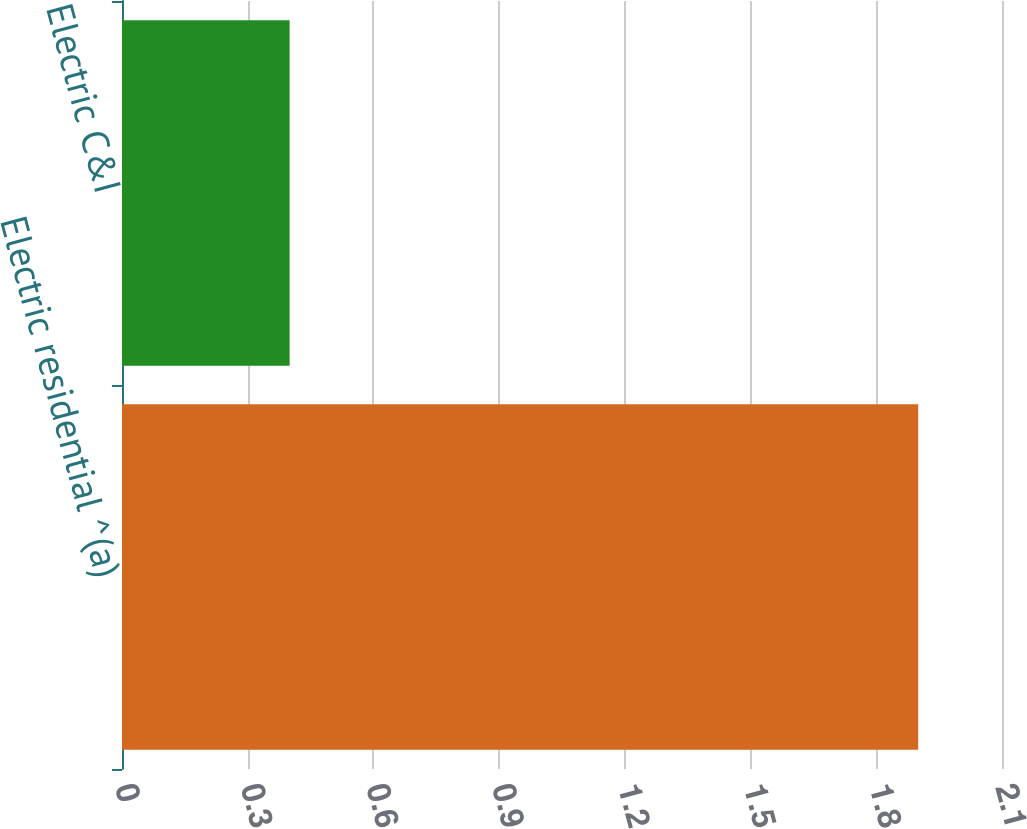Convert chart. <chart><loc_0><loc_0><loc_500><loc_500><bar_chart><fcel>Electric residential ^(a)<fcel>Electric C&I<nl><fcel>1.9<fcel>0.4<nl></chart> 